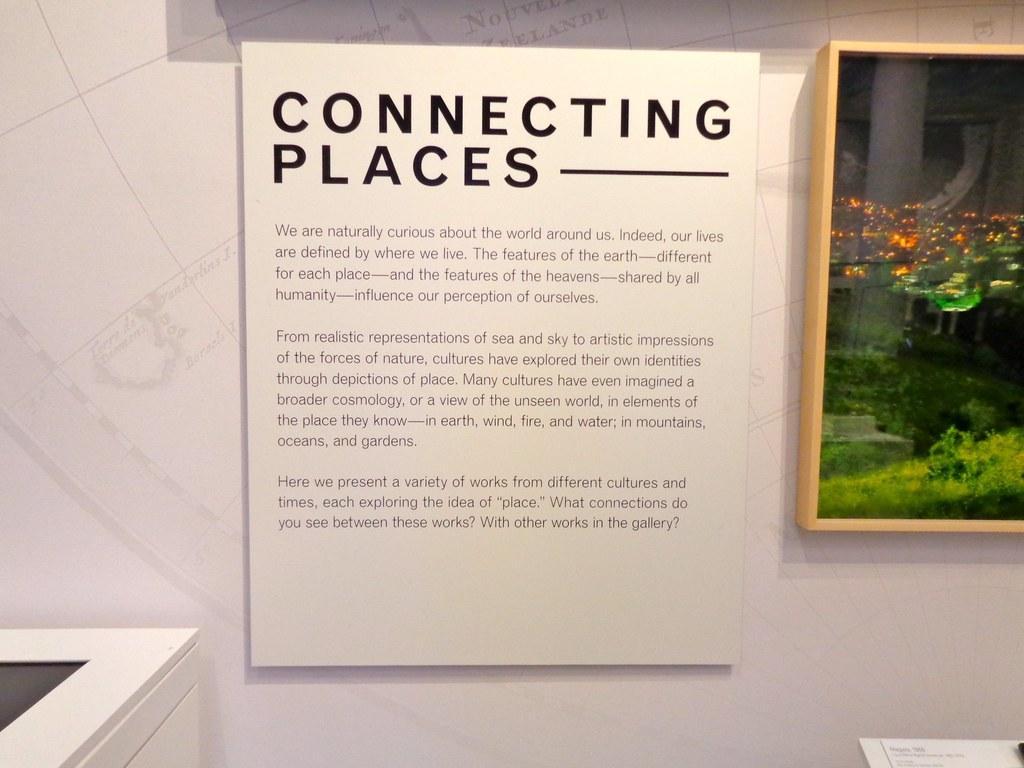In one or two sentences, can you explain what this image depicts? In this image we can see a photo frame and a poster with some text on the wall, also we can see the some other objects. 